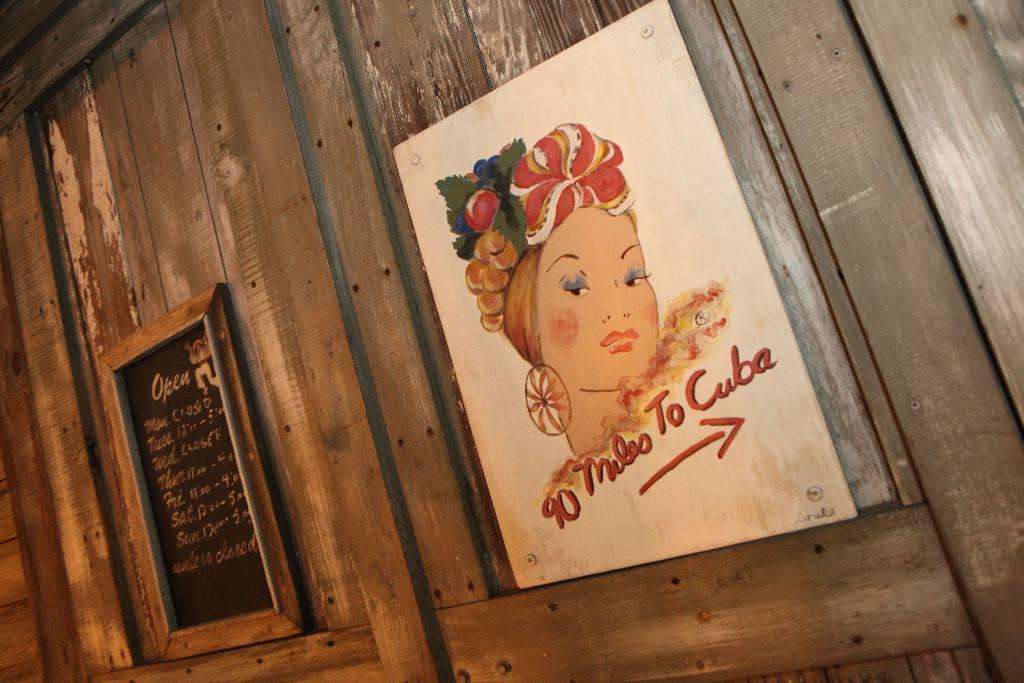How many miles is it to cuba?
Your response must be concise. 90. 